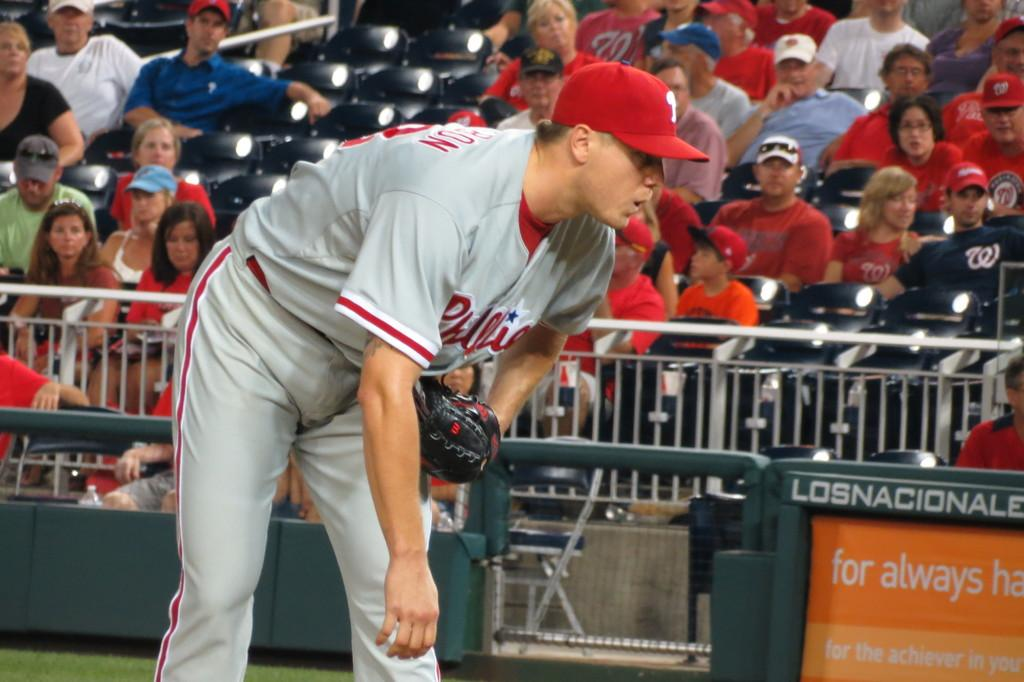Provide a one-sentence caption for the provided image. The player from Phillies is bending over while waiting. 